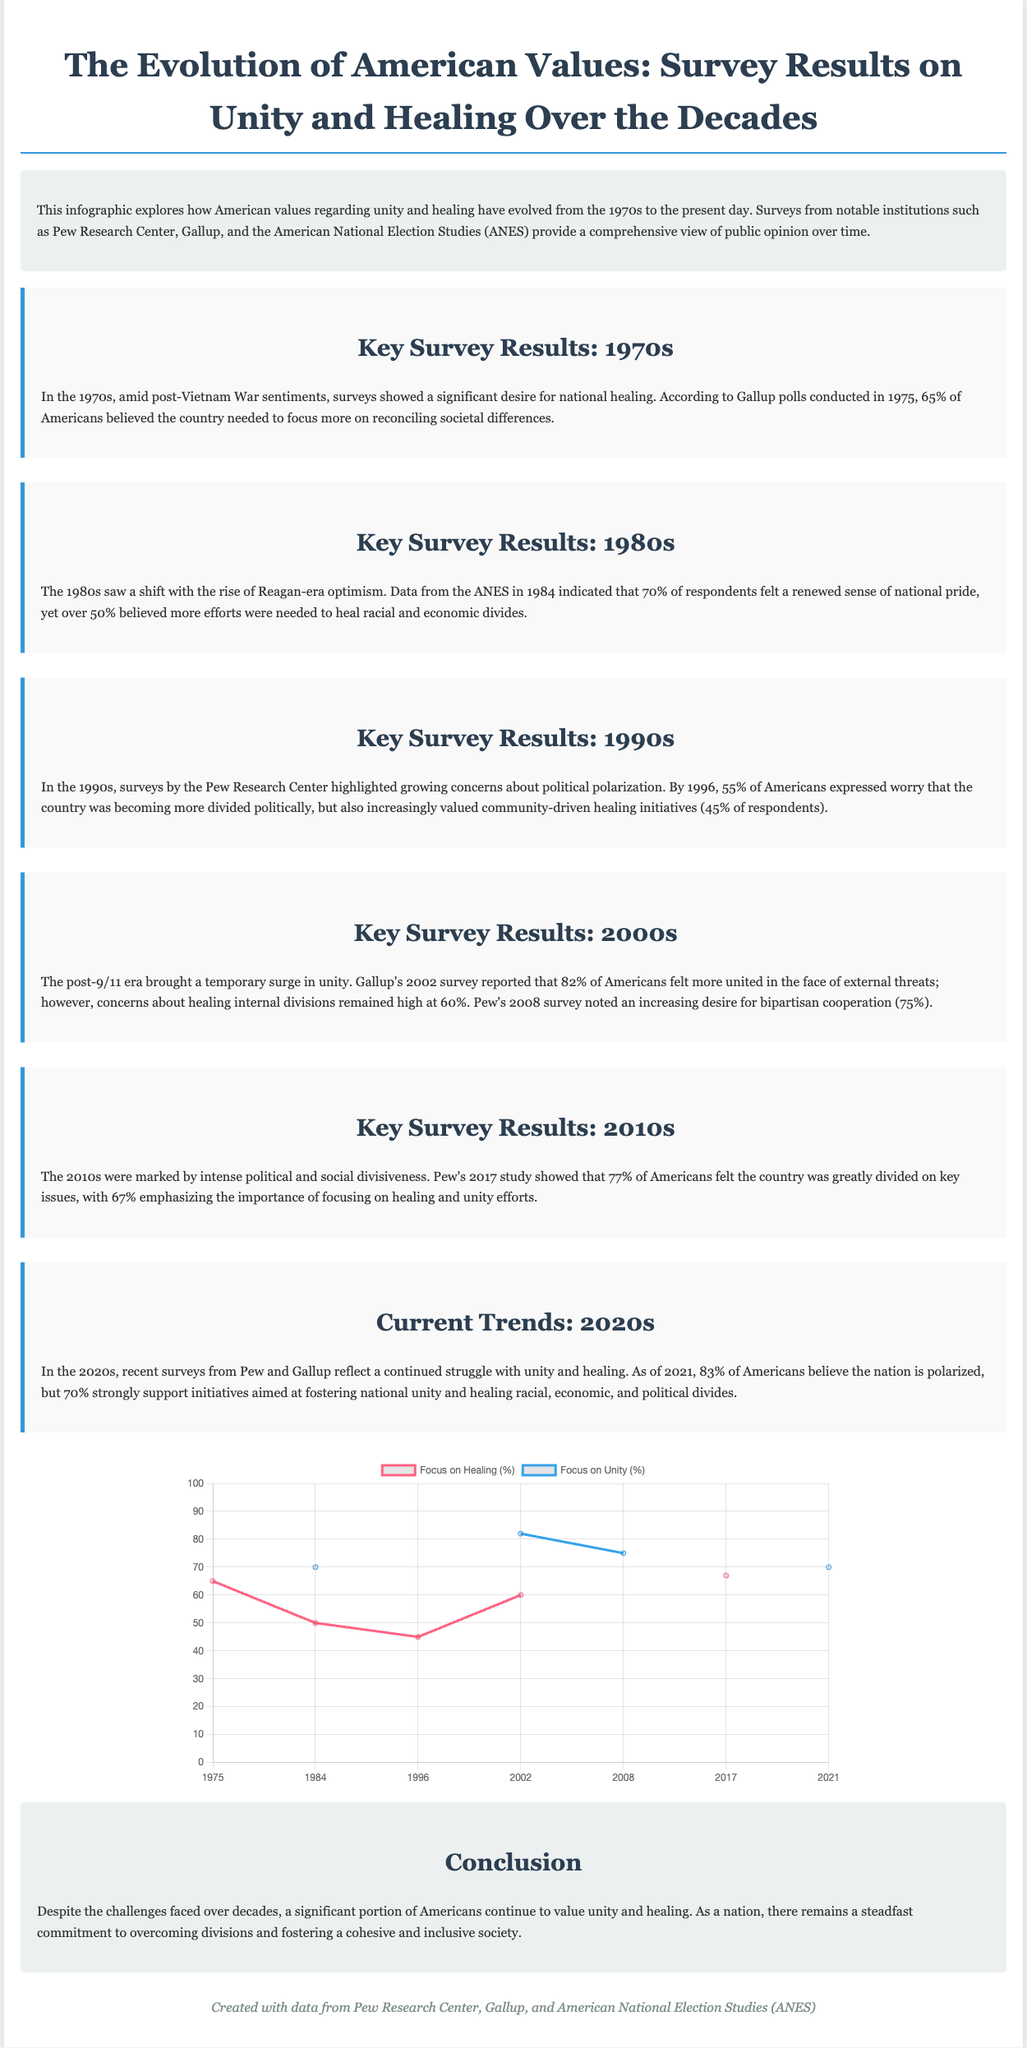What percentage of Americans in 1975 believed the country needed to focus on reconciliation? The document states that 65% of Americans believed the country needed to focus more on reconciling societal differences in 1975.
Answer: 65% What year had the highest percentage of Americans feeling united after an external threat? According to the document, the highest percentage (82%) feeling united occurred in 2002 after 9/11.
Answer: 2002 In which decade did the desire for healing initiatives rise to 45%? The 1990s saw an increase where 45% of respondents valued community-driven healing initiatives by 1996.
Answer: 1990s What was the percentage of Americans in 2017 that felt the country was greatly divided? The document states that 77% of Americans felt the country was greatly divided on key issues in 2017.
Answer: 77% What trend regarding national unity was noted at the beginning of the 2020s? The document notes that by 2021, 83% of Americans believed the nation is polarized while 70% supported healing initiatives.
Answer: 70% What percentage of Americans in 1984 felt a renewed sense of national pride? In 1984, 70% of respondents felt a renewed sense of national pride.
Answer: 70% Where did the data for the infographic come from? The document cites Pew Research Center, Gallup, and American National Election Studies (ANES) as sources of data.
Answer: Pew Research Center, Gallup, and ANES 